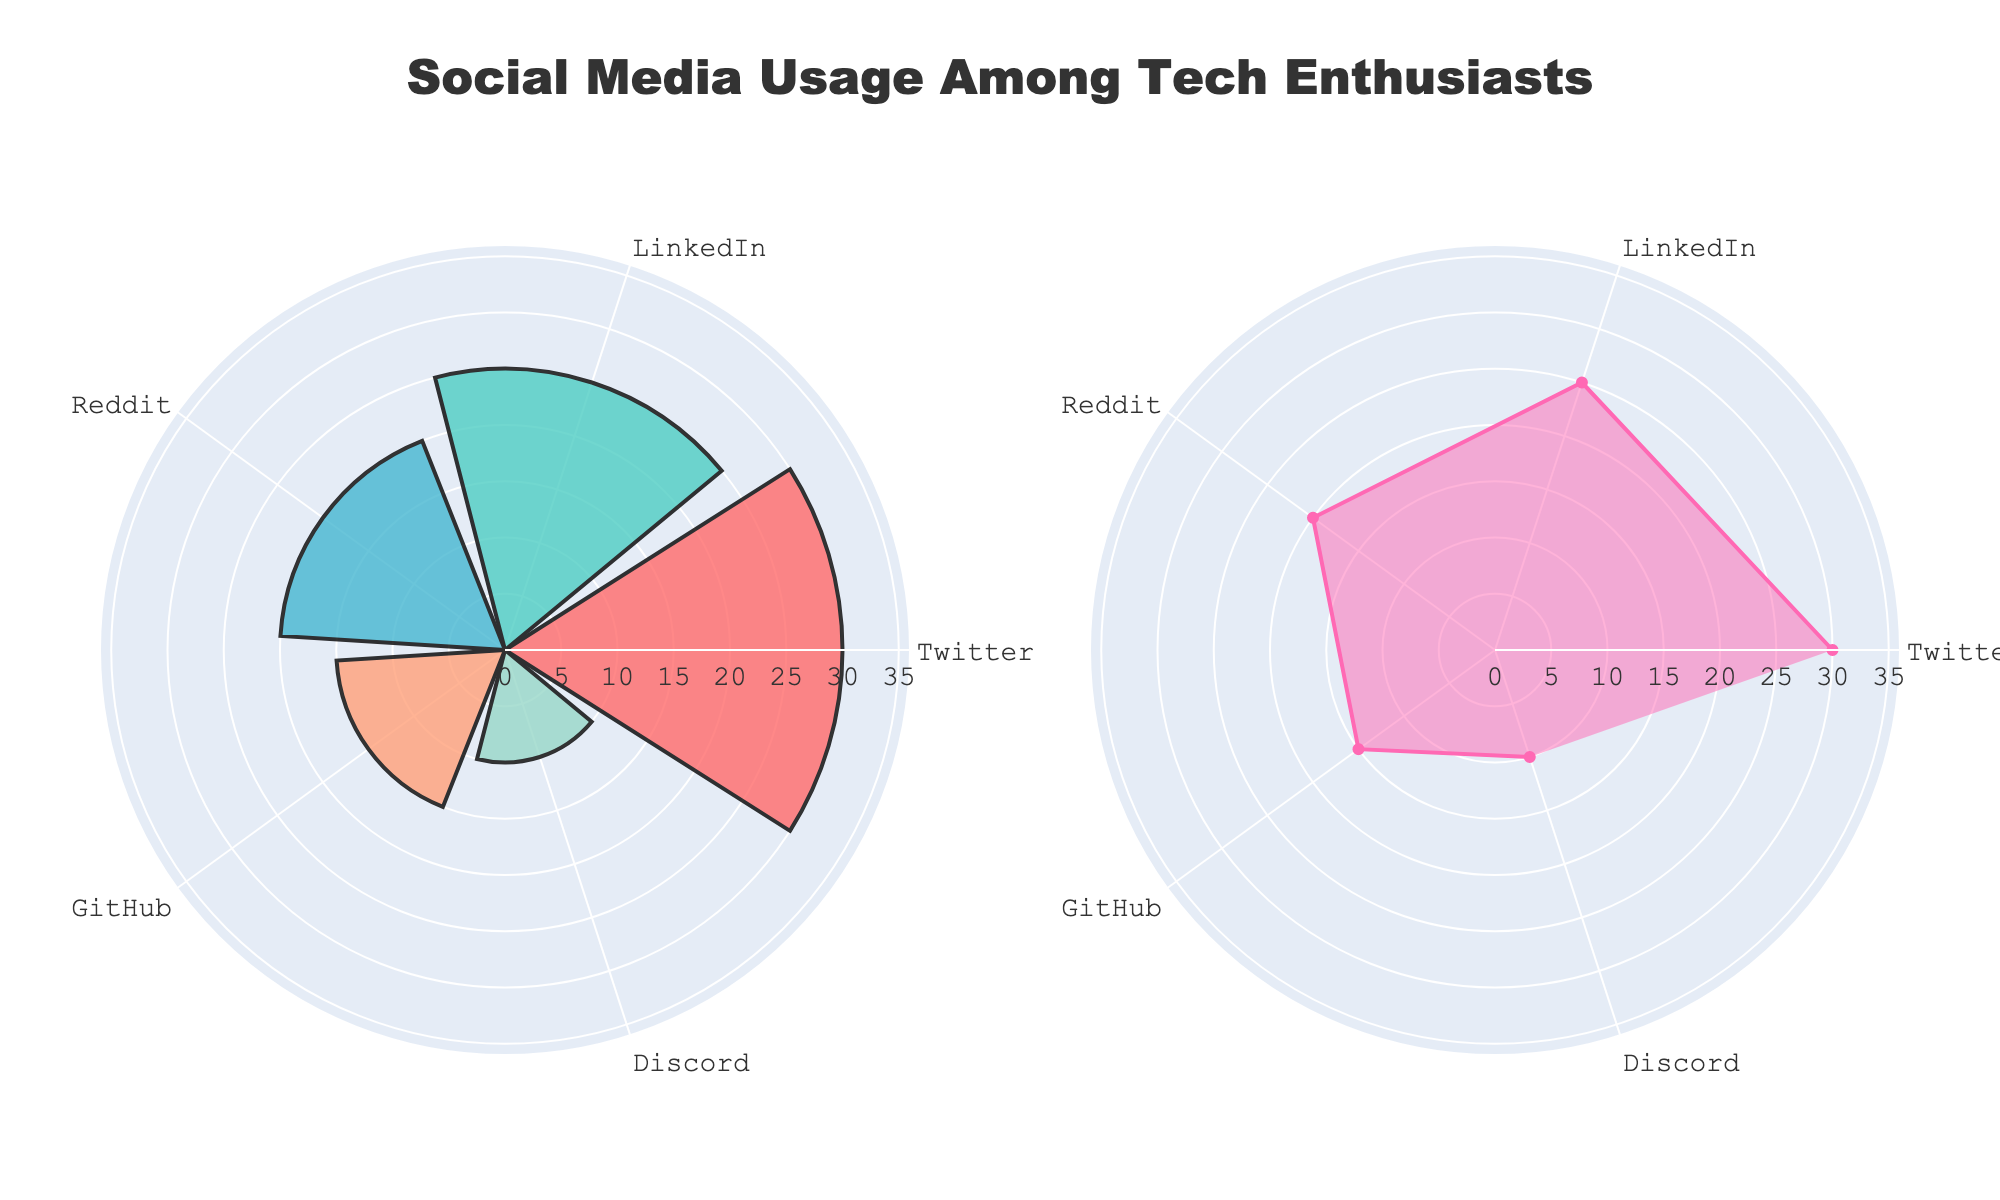What is the title of the figure? The title of the figure is displayed at the top and is designed to summarize the visualization for the viewer. The title is "Social Media Usage Among Tech Enthusiasts."
Answer: Social Media Usage Among Tech Enthusiasts How many social media platforms are shown in the figure? Count the number of labels, which represent the different social media platforms, to determine this. There are labels for Twitter, LinkedIn, Reddit, GitHub, and Discord, making a total of 5 platforms.
Answer: 5 Which social media platform has the highest usage percentage? Compare the values for all platforms. The bar for Twitter is the largest in the barpolar and the scatterpolar chart, indicating it has the highest usage percentage.
Answer: Twitter What is the combined usage percentage of LinkedIn and Discord? Identify the respective usage percentages for LinkedIn (25%) and Discord (10%), and then add them up. 25% + 10% = 35%.
Answer: 35% What is the color used for the bar representing GitHub? In the barpolar plot, the bars are colored distinctly. The bar representing GitHub uses a light orange or salmon color.
Answer: Light orange Which platform has the smallest representation in the charts? Look at the values and identify the smallest percentage. Discord has the smallest usage percentage at 10%.
Answer: Discord How much greater is the usage of Reddit than that of GitHub? Subtract the usage percentage of GitHub (15%) from that of Reddit (20%). 20% - 15% = 5%.
Answer: 5% Between LinkedIn and Reddit, which one has a higher usage percentage? Compare the values given for LinkedIn (25%) and Reddit (20%). LinkedIn has a higher usage percentage.
Answer: LinkedIn Is the radial axis range on both subplots identical? Evaluate the radial axis range specified in the layout settings of both subplots. Both polar plots have a radial axis range extending to 120% of the maximum usage percentage, ensuring they match.
Answer: Yes What is the usage percentage difference between the platform with the highest usage and the platform with the lowest usage? Identify that Twitter has the highest usage at 30% and Discord the lowest at 10%. Subtract the smallest value from the largest: 30% - 10% = 20%.
Answer: 20% 